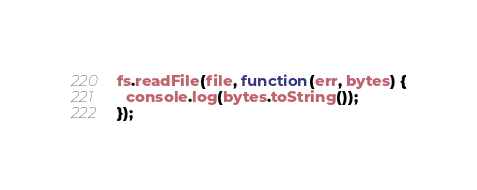<code> <loc_0><loc_0><loc_500><loc_500><_JavaScript_>
fs.readFile(file, function(err, bytes) {
  console.log(bytes.toString());
});</code> 